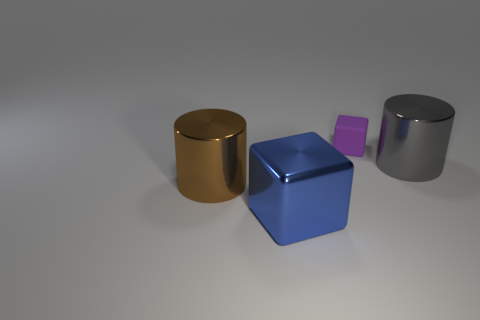Add 4 brown shiny objects. How many objects exist? 8 Subtract 1 cubes. How many cubes are left? 1 Subtract all purple blocks. Subtract all yellow cylinders. How many blocks are left? 1 Subtract all gray spheres. How many red blocks are left? 0 Subtract all big metal blocks. Subtract all tiny matte cubes. How many objects are left? 2 Add 4 large brown shiny cylinders. How many large brown shiny cylinders are left? 5 Add 2 big brown things. How many big brown things exist? 3 Subtract all gray cylinders. How many cylinders are left? 1 Subtract 0 gray blocks. How many objects are left? 4 